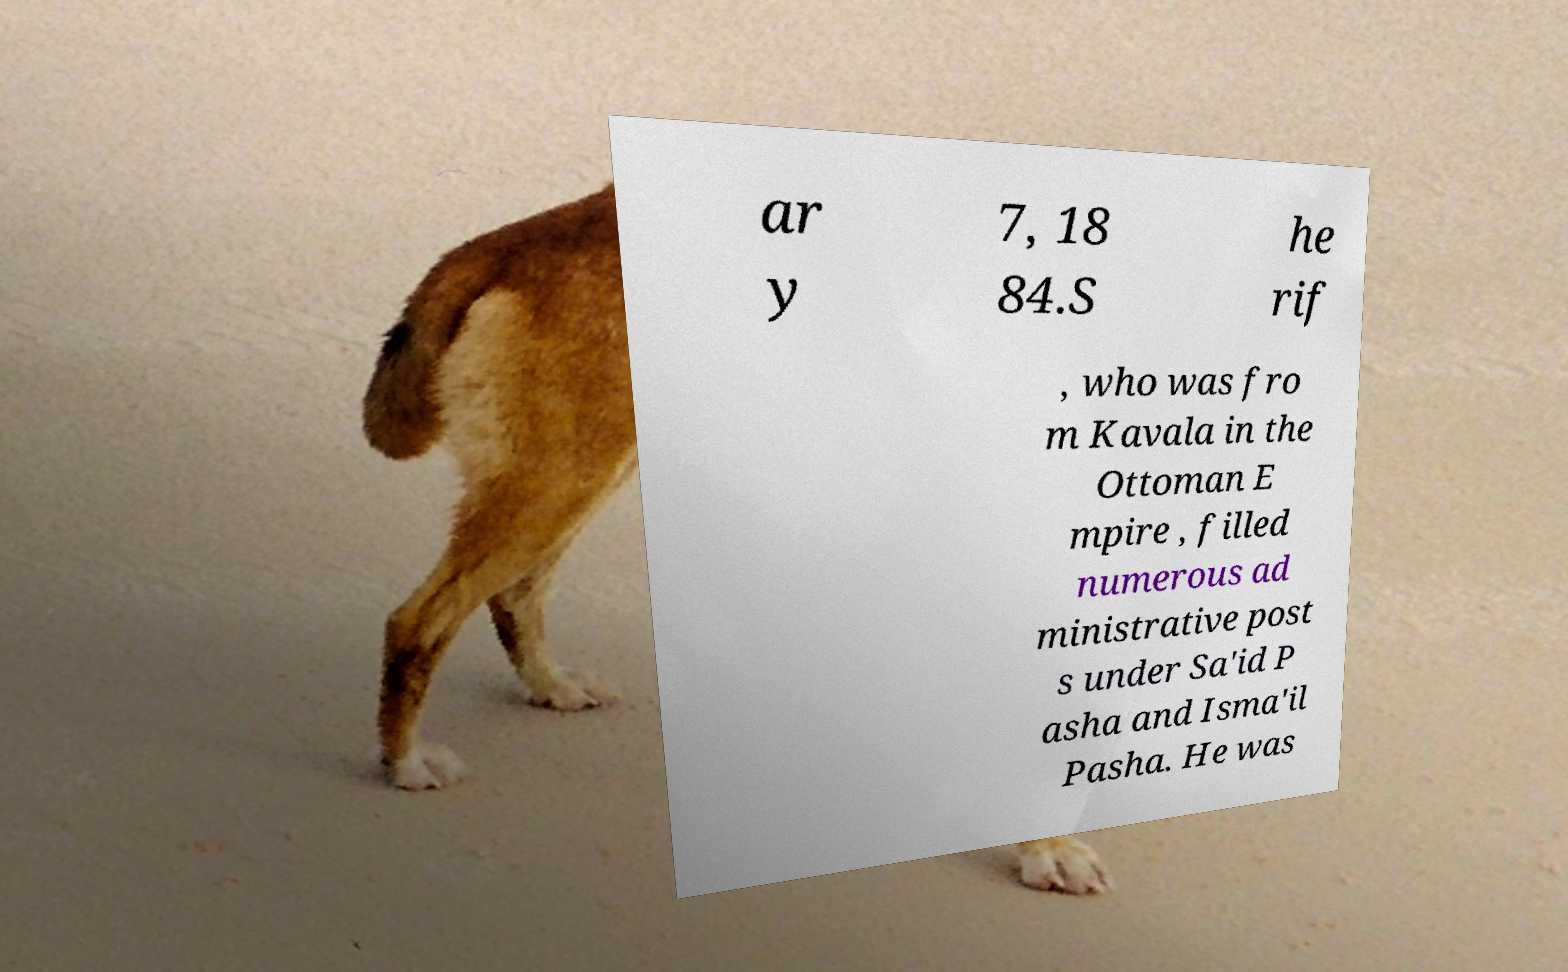There's text embedded in this image that I need extracted. Can you transcribe it verbatim? ar y 7, 18 84.S he rif , who was fro m Kavala in the Ottoman E mpire , filled numerous ad ministrative post s under Sa'id P asha and Isma'il Pasha. He was 